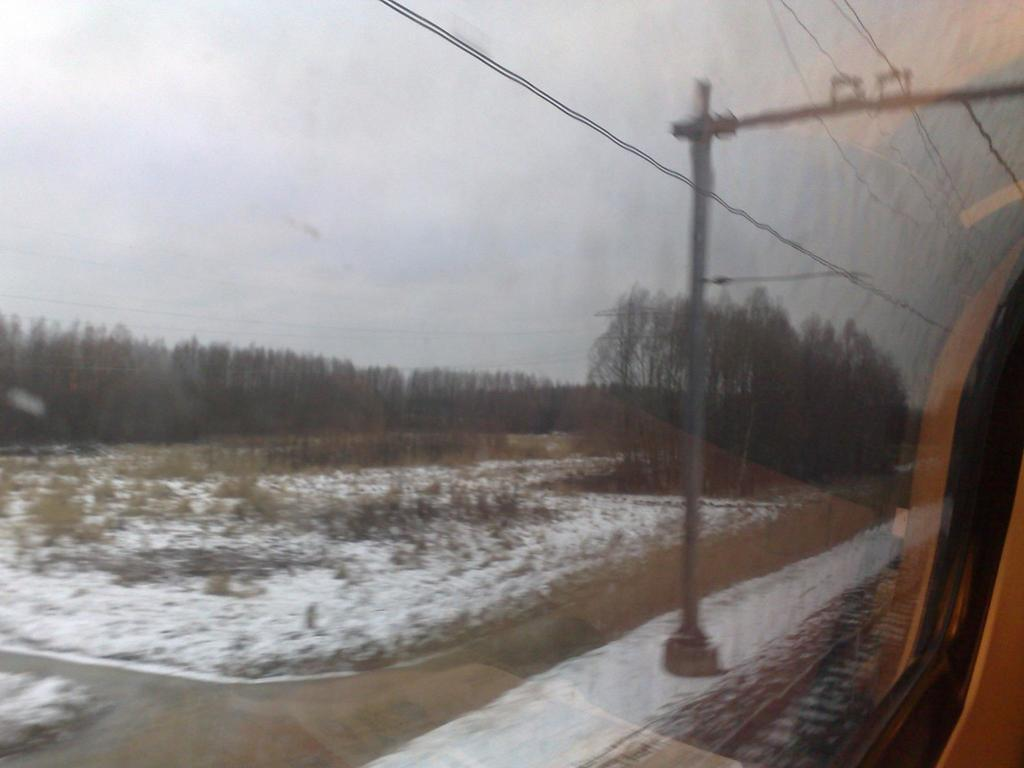What type of door is shown in the image? The image appears to show a glass door. What is attached to the current pole in the image? There are wires attached to the current pole in the image. What is the weather like in the image? The image depicts snow, indicating a cold and wintry scene. What type of vegetation is visible in the image? Trees and plants are visible in the image. What type of transportation infrastructure is present in the image? There is a rail track in the image. Where is the throne located in the image? There is no throne present in the image. What type of animal is biting the current pole in the image? There are no animals present in the image, and the current pole is not being bitten. 